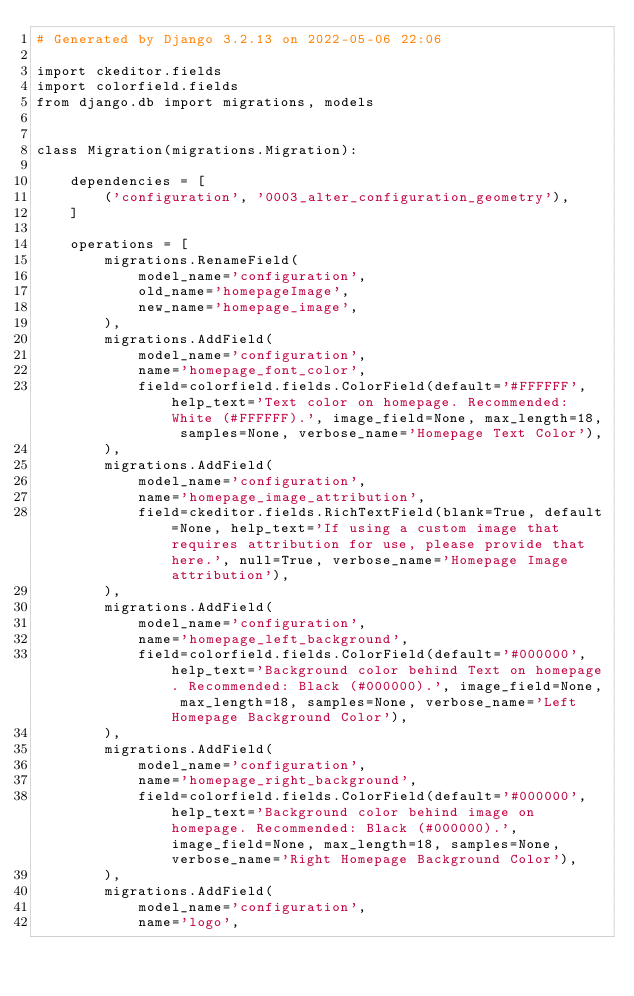<code> <loc_0><loc_0><loc_500><loc_500><_Python_># Generated by Django 3.2.13 on 2022-05-06 22:06

import ckeditor.fields
import colorfield.fields
from django.db import migrations, models


class Migration(migrations.Migration):

    dependencies = [
        ('configuration', '0003_alter_configuration_geometry'),
    ]

    operations = [
        migrations.RenameField(
            model_name='configuration',
            old_name='homepageImage',
            new_name='homepage_image',
        ),
        migrations.AddField(
            model_name='configuration',
            name='homepage_font_color',
            field=colorfield.fields.ColorField(default='#FFFFFF', help_text='Text color on homepage. Recommended: White (#FFFFFF).', image_field=None, max_length=18, samples=None, verbose_name='Homepage Text Color'),
        ),
        migrations.AddField(
            model_name='configuration',
            name='homepage_image_attribution',
            field=ckeditor.fields.RichTextField(blank=True, default=None, help_text='If using a custom image that requires attribution for use, please provide that here.', null=True, verbose_name='Homepage Image attribution'),
        ),
        migrations.AddField(
            model_name='configuration',
            name='homepage_left_background',
            field=colorfield.fields.ColorField(default='#000000', help_text='Background color behind Text on homepage. Recommended: Black (#000000).', image_field=None, max_length=18, samples=None, verbose_name='Left Homepage Background Color'),
        ),
        migrations.AddField(
            model_name='configuration',
            name='homepage_right_background',
            field=colorfield.fields.ColorField(default='#000000', help_text='Background color behind image on homepage. Recommended: Black (#000000).', image_field=None, max_length=18, samples=None, verbose_name='Right Homepage Background Color'),
        ),
        migrations.AddField(
            model_name='configuration',
            name='logo',</code> 